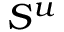<formula> <loc_0><loc_0><loc_500><loc_500>S ^ { u }</formula> 